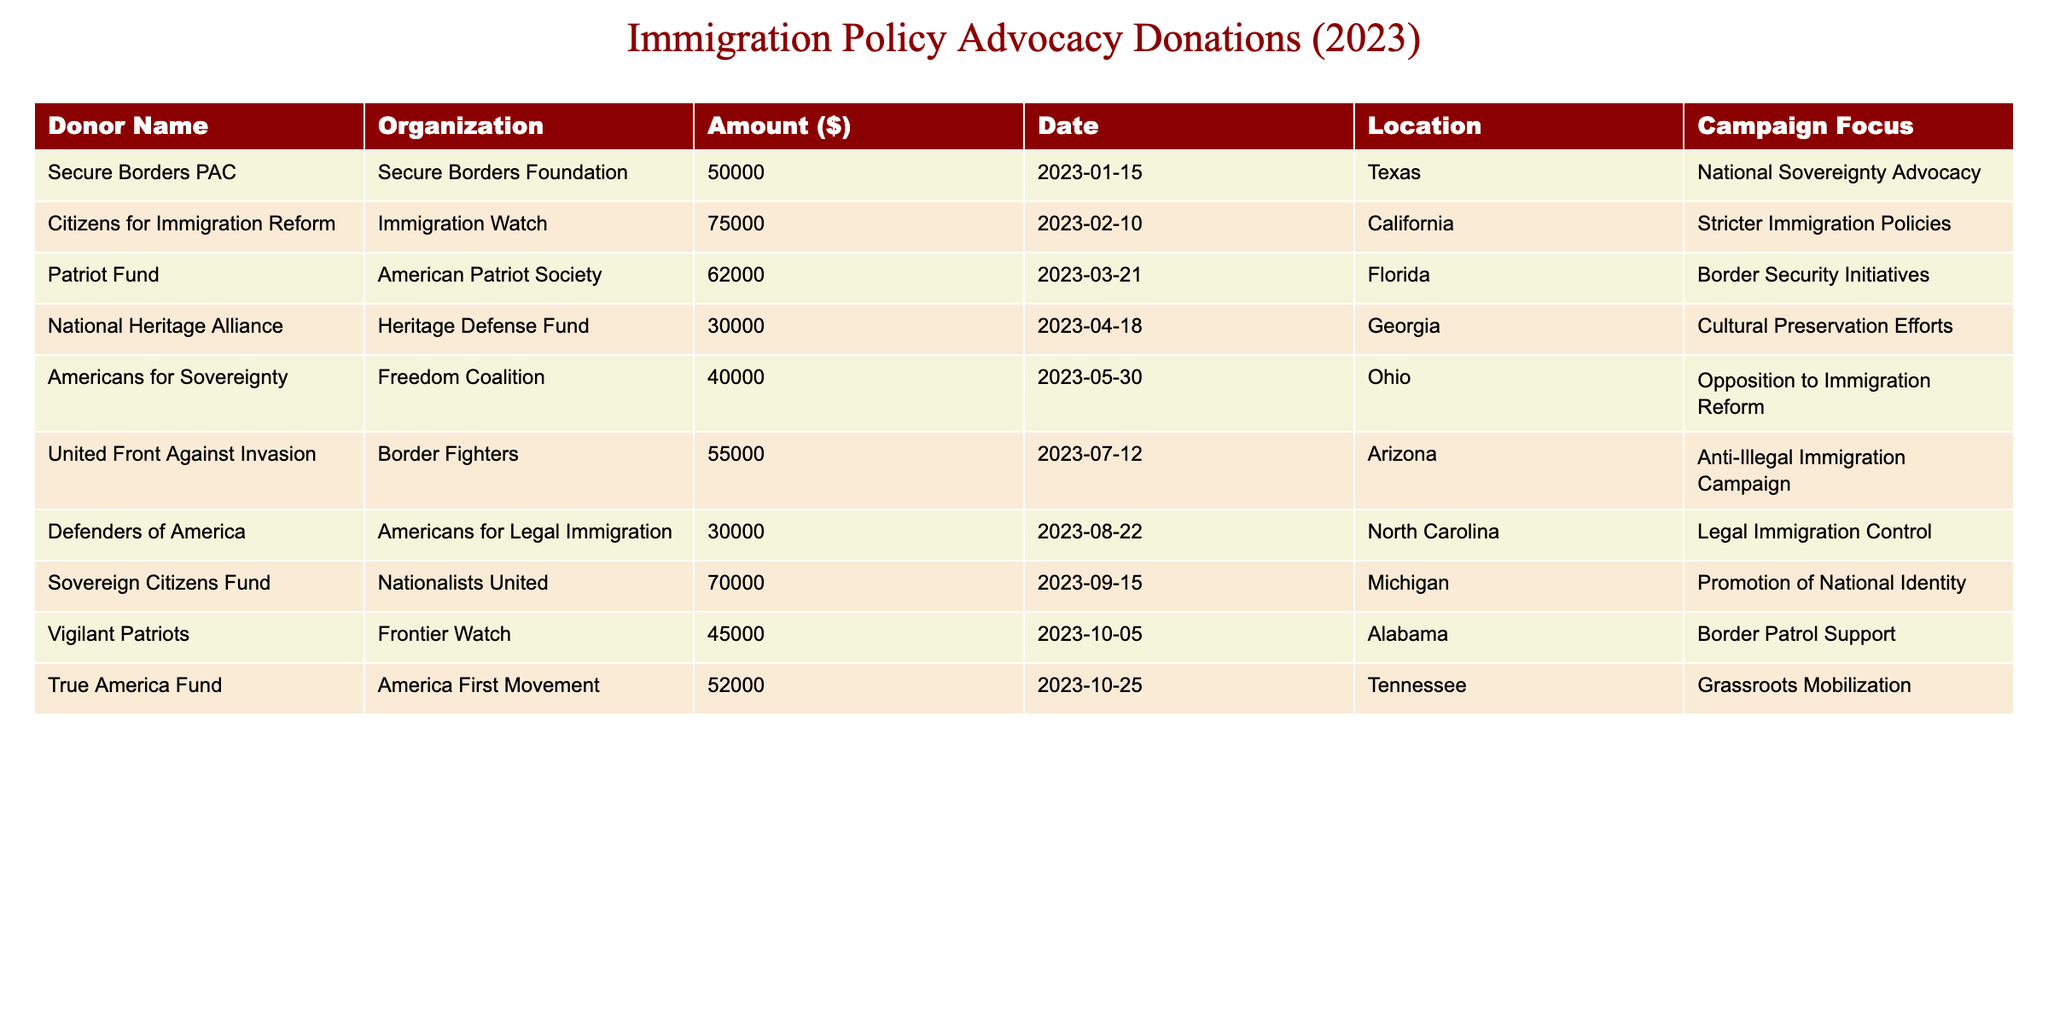What is the total amount of donations received from the donors located in Texas? The table shows one donor from Texas: Secure Borders PAC, contributing $50,000. Since there are no other donors from Texas, the total amount is just this single contribution.
Answer: 50000 Which organization received the largest donation and what was the amount? The table highlights that Citizens for Immigration Reform received the largest donation of $75,000. It's the highest value seen in the "Amount ($)" column.
Answer: 75000 How many donations are focused on "Stricter Immigration Policies"? According to the table, there are two donations specifically focused on "Stricter Immigration Policies" - one from Citizens for Immigration Reform ($75,000) and one from Americans for Sovereignty ($40,000), totaling two entries in the "Campaign Focus" column that match this criterion.
Answer: 2 What is the average donation amount across all organizations listed? To find the average, we add all the donation amounts: 50000 + 75000 + 62000 + 30000 + 40000 + 55000 + 30000 + 70000 + 45000 + 52000 = 4,570,000. There are 10 donations, so we divide 4,570,000 by 10, resulting in an average of $57,000.
Answer: 57000 Is the contribution of Sovereign Citizens Fund higher than the sum of contributions from the organizations based in North Carolina? The Sovereign Citizens Fund contributed $70,000. The contribution from Defenders of America in North Carolina was $30,000. Comparing both, 30,000 < 70,000, which indicates the contribution from Sovereign Citizens Fund is indeed higher.
Answer: Yes What is the total amount donated by the organizations advocating for "Cultural Preservation Efforts"? The only organization listed under "Cultural Preservation Efforts" is the National Heritage Alliance, which contributed $30,000. Since there's just one entry, the total donation is simply $30,000.
Answer: 30000 How many states are represented in the donation table? By reviewing the locations of the donors, we find that they come from Texas, California, Florida, Georgia, Ohio, Arizona, North Carolina, Michigan, Alabama, and Tennessee, which totals 10 unique states.
Answer: 10 Which donor organization contributed the amount closest to $50,000 without going over? Looking at the table, the closest contribution to $50,000 that does not exceed this amount is from Vigilant Patriots at $45,000. This is less than $50,000 while being the highest value that meets the requirement.
Answer: 45000 What is the total combined contribution amount from organizations located in Michigan and Florida? The contribution from Michigan, Sovereign Citizens Fund, amounts to $70,000, and from Florida, Patriot Fund amounts to $62,000. Adding these two sums together gives $70,000 + $62,000 = $132,000 as the total amount.
Answer: 132000 